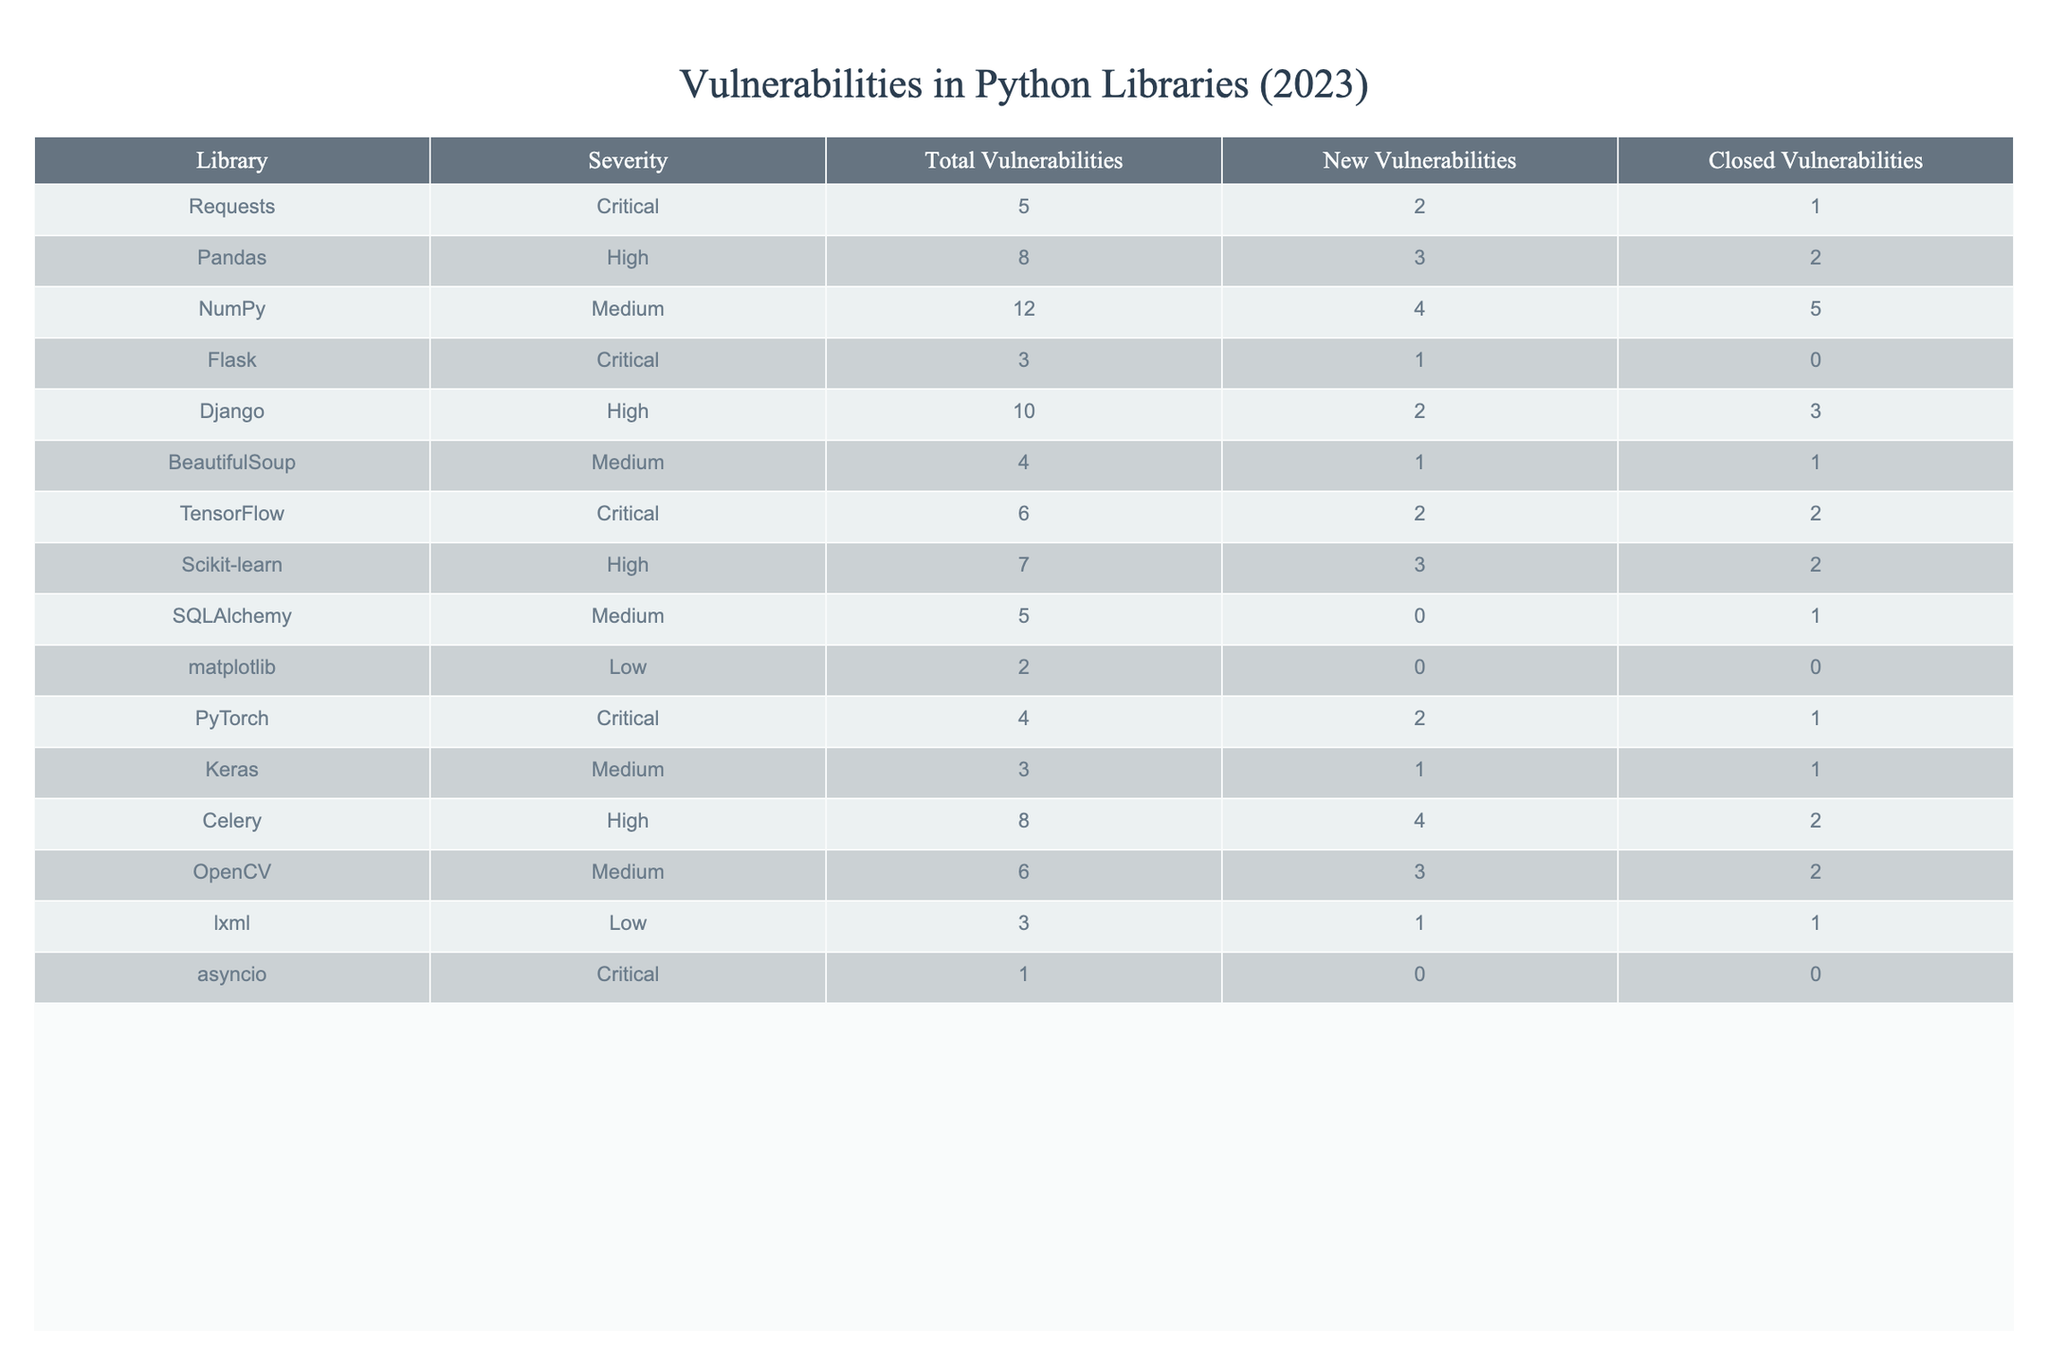What is the library with the highest total number of vulnerabilities? By examining the 'Total Vulnerabilities' column, I can see that NumPy has the highest value with 12.
Answer: NumPy How many vulnerabilities does Flask have? Referring to the 'Total Vulnerabilities' column, the value for Flask is 3.
Answer: 3 What is the total number of critical vulnerabilities across all libraries? To find this, I sum the critical vulnerabilities: 5 (Requests) + 3 (Flask) + 6 (TensorFlow) + 4 (PyTorch) + 1 (asyncio) = 19.
Answer: 19 Which library has the lowest number of new vulnerabilities? Looking at the 'New Vulnerabilities' column, asyncio has the least with a value of 0.
Answer: asyncio How many vulnerabilities has Keras closed? The 'Closed Vulnerabilities' column for Keras shows a total of 1.
Answer: 1 What is the total count of medium severity vulnerabilities? The medium vulnerabilities are: 12 (NumPy) + 4 (BeautifulSoup) + 5 (SQLAlchemy) + 6 (OpenCV) + 3 (Keras) = 30.
Answer: 30 Are there any libraries with no closed vulnerabilities? By checking the 'Closed Vulnerabilities' column, I see that Flask and asyncio both have a value of 0, which means they have no closed vulnerabilities.
Answer: Yes What is the difference between the total vulnerabilities of the highest and lowest severity libraries? The library with the highest total vulnerabilities is NumPy with 12, and the lowest is asyncio with 1. The difference is 12 - 1 = 11.
Answer: 11 Which severity category has the most total vulnerabilities? By summing up the total vulnerabilities by category, I find: Critical (19), High (25), Medium (30), and Low (5). Medium has the most with 30.
Answer: Medium How many new vulnerabilities does the Django library have compared to the Requests library? Django has 2 new vulnerabilities, while Requests has 2 as well. The difference is 2 - 2 = 0.
Answer: 0 